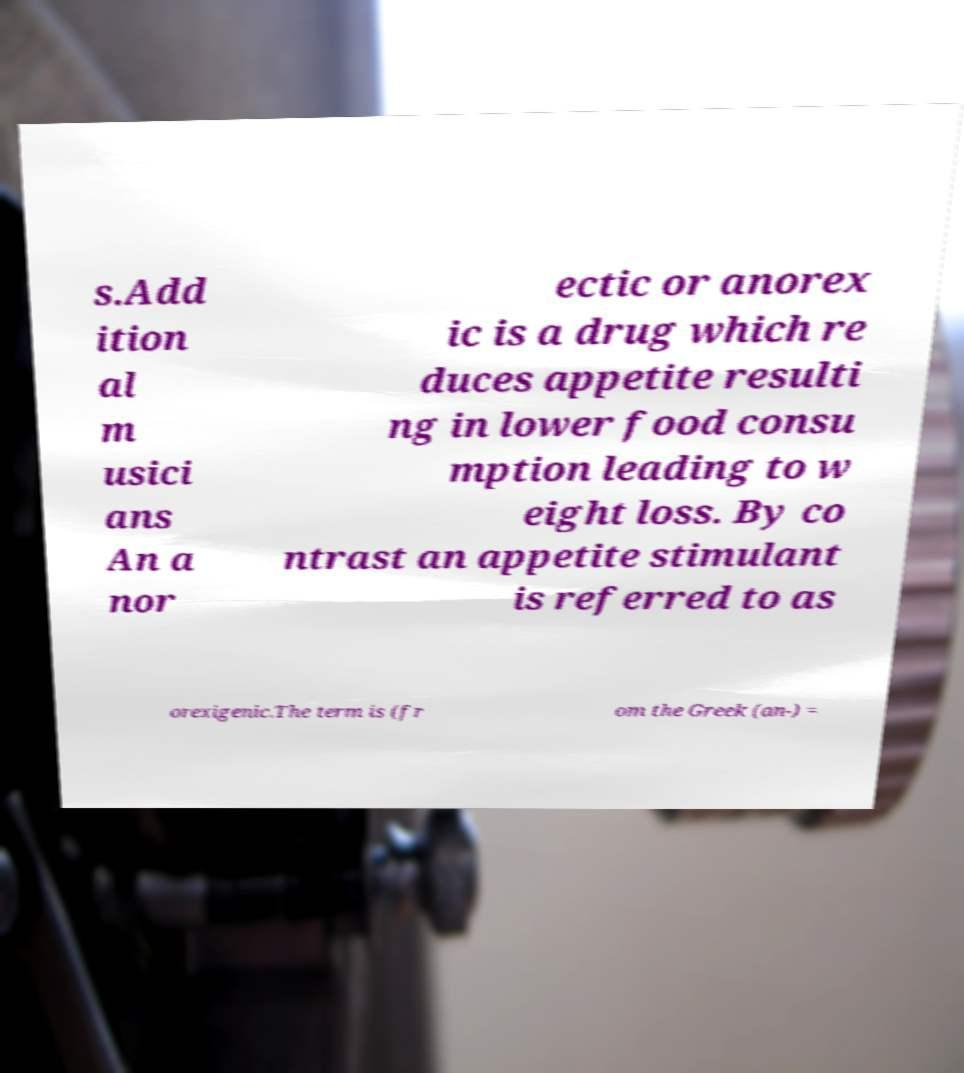Could you assist in decoding the text presented in this image and type it out clearly? s.Add ition al m usici ans An a nor ectic or anorex ic is a drug which re duces appetite resulti ng in lower food consu mption leading to w eight loss. By co ntrast an appetite stimulant is referred to as orexigenic.The term is (fr om the Greek (an-) = 